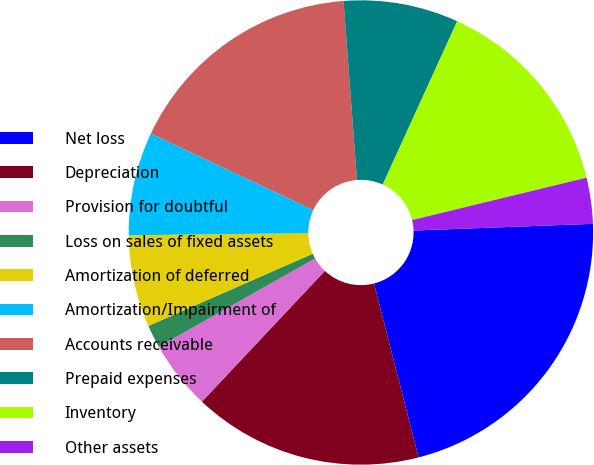<chart> <loc_0><loc_0><loc_500><loc_500><pie_chart><fcel>Net loss<fcel>Depreciation<fcel>Provision for doubtful<fcel>Loss on sales of fixed assets<fcel>Amortization of deferred<fcel>Amortization/Impairment of<fcel>Accounts receivable<fcel>Prepaid expenses<fcel>Inventory<fcel>Other assets<nl><fcel>21.6%<fcel>16.0%<fcel>4.8%<fcel>1.6%<fcel>6.4%<fcel>7.2%<fcel>16.8%<fcel>8.0%<fcel>14.4%<fcel>3.2%<nl></chart> 